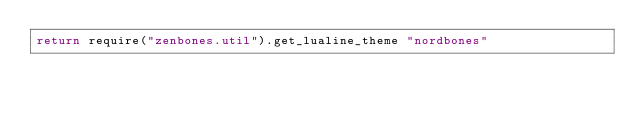Convert code to text. <code><loc_0><loc_0><loc_500><loc_500><_Lua_>return require("zenbones.util").get_lualine_theme "nordbones"
</code> 